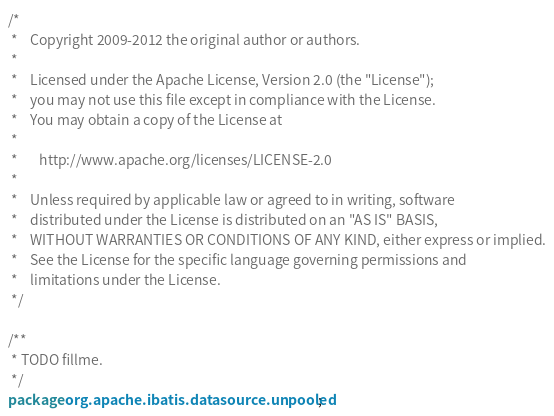<code> <loc_0><loc_0><loc_500><loc_500><_Java_>/*
 *    Copyright 2009-2012 the original author or authors.
 *
 *    Licensed under the Apache License, Version 2.0 (the "License");
 *    you may not use this file except in compliance with the License.
 *    You may obtain a copy of the License at
 *
 *       http://www.apache.org/licenses/LICENSE-2.0
 *
 *    Unless required by applicable law or agreed to in writing, software
 *    distributed under the License is distributed on an "AS IS" BASIS,
 *    WITHOUT WARRANTIES OR CONDITIONS OF ANY KIND, either express or implied.
 *    See the License for the specific language governing permissions and
 *    limitations under the License.
 */

/**
 * TODO fillme.
 */
package org.apache.ibatis.datasource.unpooled;
</code> 